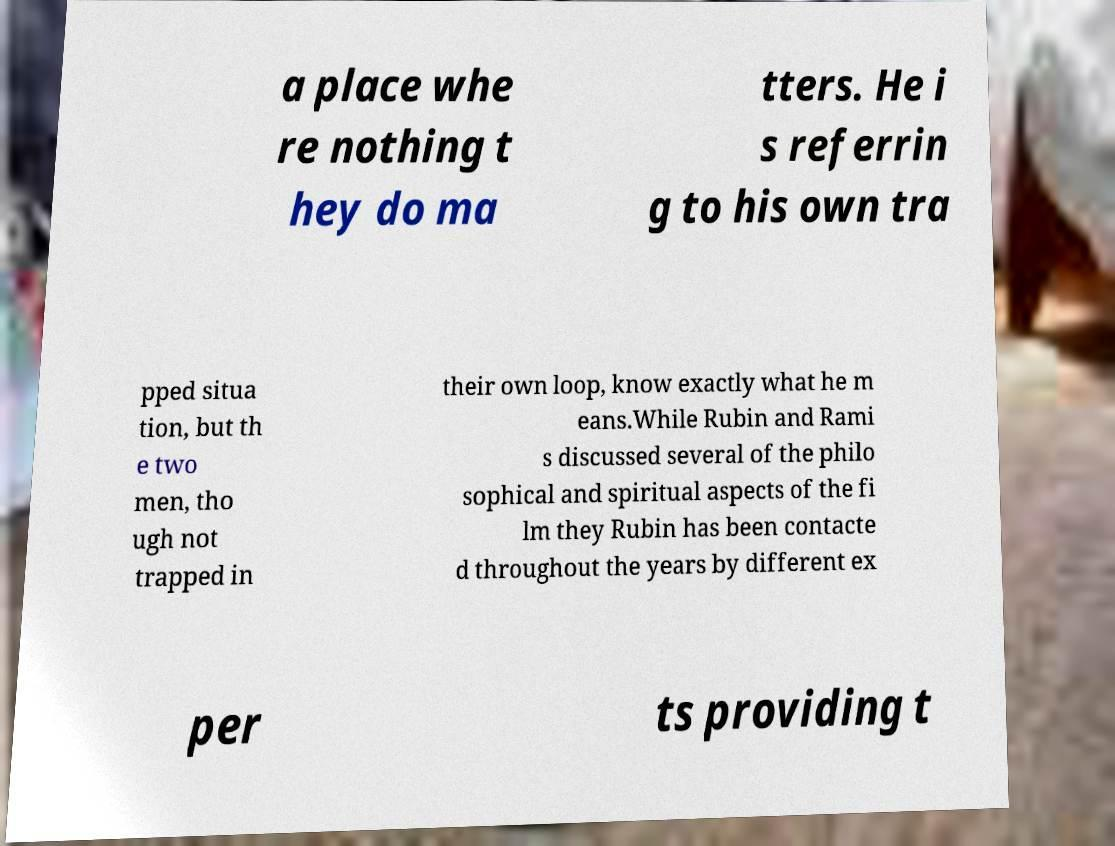What messages or text are displayed in this image? I need them in a readable, typed format. a place whe re nothing t hey do ma tters. He i s referrin g to his own tra pped situa tion, but th e two men, tho ugh not trapped in their own loop, know exactly what he m eans.While Rubin and Rami s discussed several of the philo sophical and spiritual aspects of the fi lm they Rubin has been contacte d throughout the years by different ex per ts providing t 